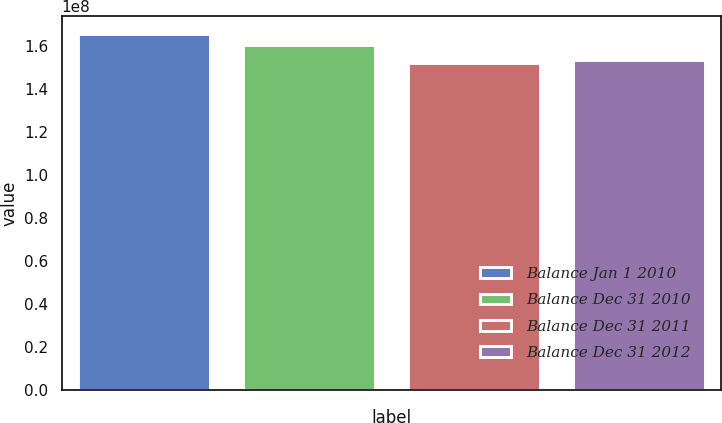Convert chart. <chart><loc_0><loc_0><loc_500><loc_500><bar_chart><fcel>Balance Jan 1 2010<fcel>Balance Dec 31 2010<fcel>Balance Dec 31 2011<fcel>Balance Dec 31 2012<nl><fcel>1.65668e+08<fcel>1.60382e+08<fcel>1.51889e+08<fcel>1.53566e+08<nl></chart> 